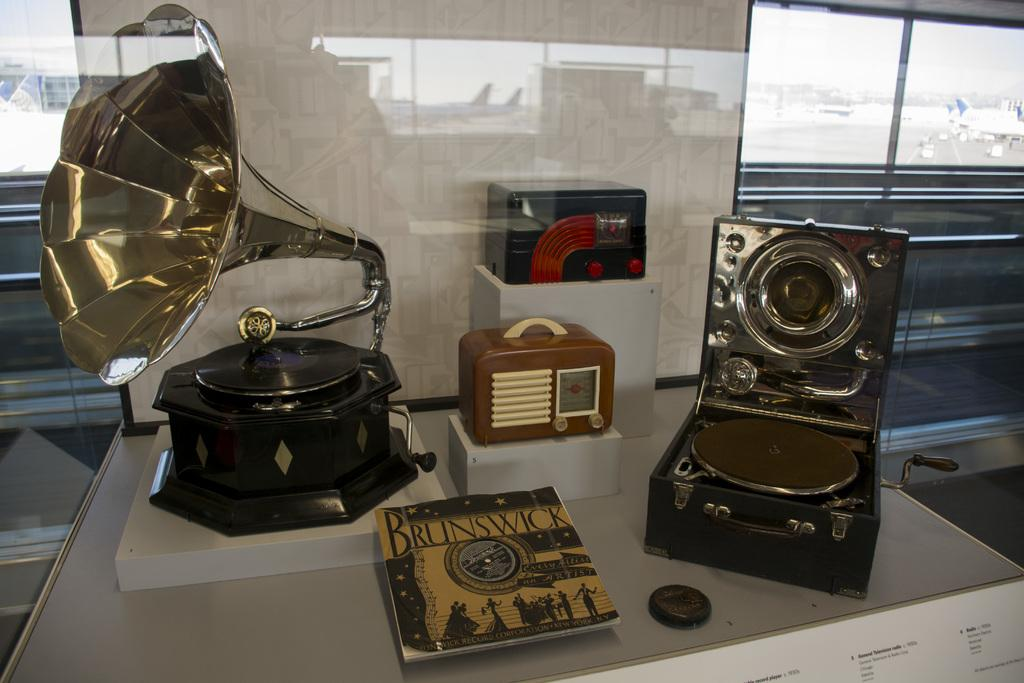What type of objects can be seen in the image? There are musical instruments in the image. Can you describe the appearance of the musical instruments? The musical instruments are in different colors. What type of crime is being committed in the image? There is no crime present in the image; it features musical instruments in different colors. Can you tell me how many boxes are visible in the image? There are no boxes present in the image; it features musical instruments in different colors. 